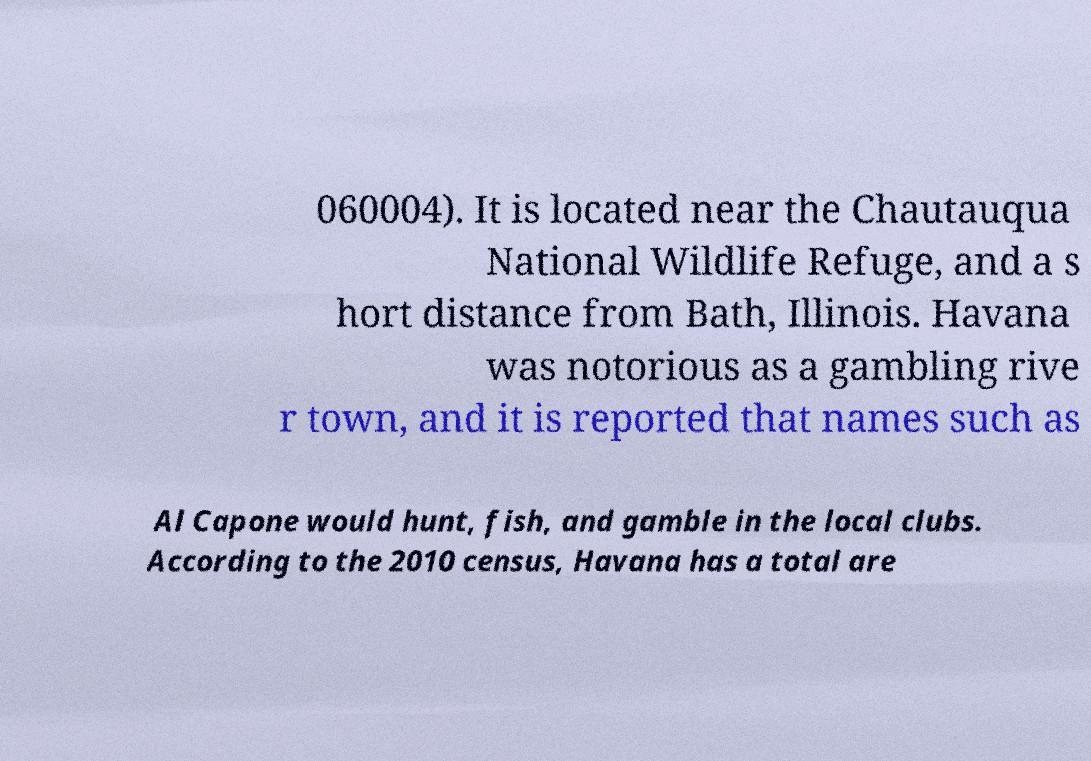For documentation purposes, I need the text within this image transcribed. Could you provide that? 060004). It is located near the Chautauqua National Wildlife Refuge, and a s hort distance from Bath, Illinois. Havana was notorious as a gambling rive r town, and it is reported that names such as Al Capone would hunt, fish, and gamble in the local clubs. According to the 2010 census, Havana has a total are 